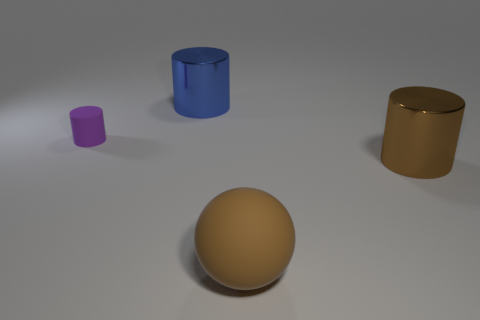What textures are visible on the objects in the image? The objects appear to have differing textures. The tiny purple cylinder has a smooth finish, similar to the matte sphere in the center, whereas the blue and gold cylinders have a slightly reflective surface. 